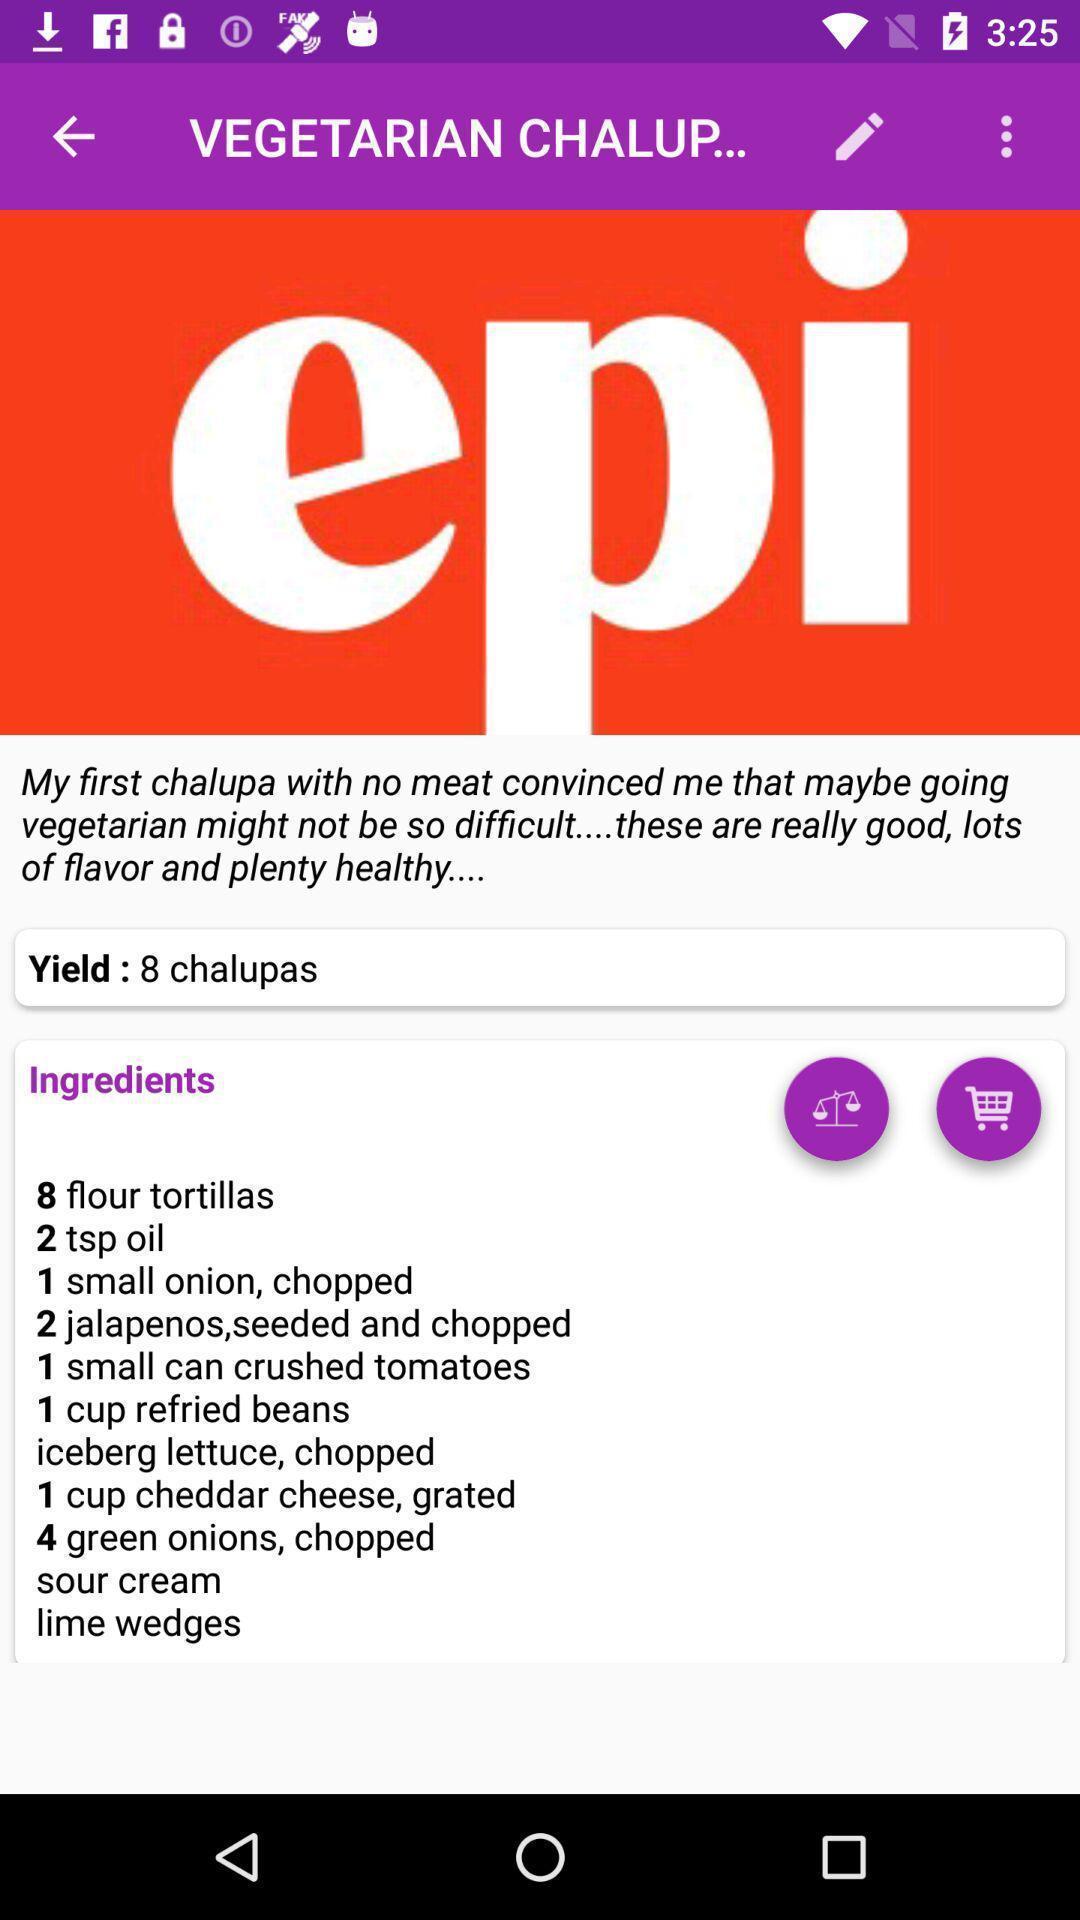Tell me about the visual elements in this screen capture. Screen displaying the ingredients of a recipe. 